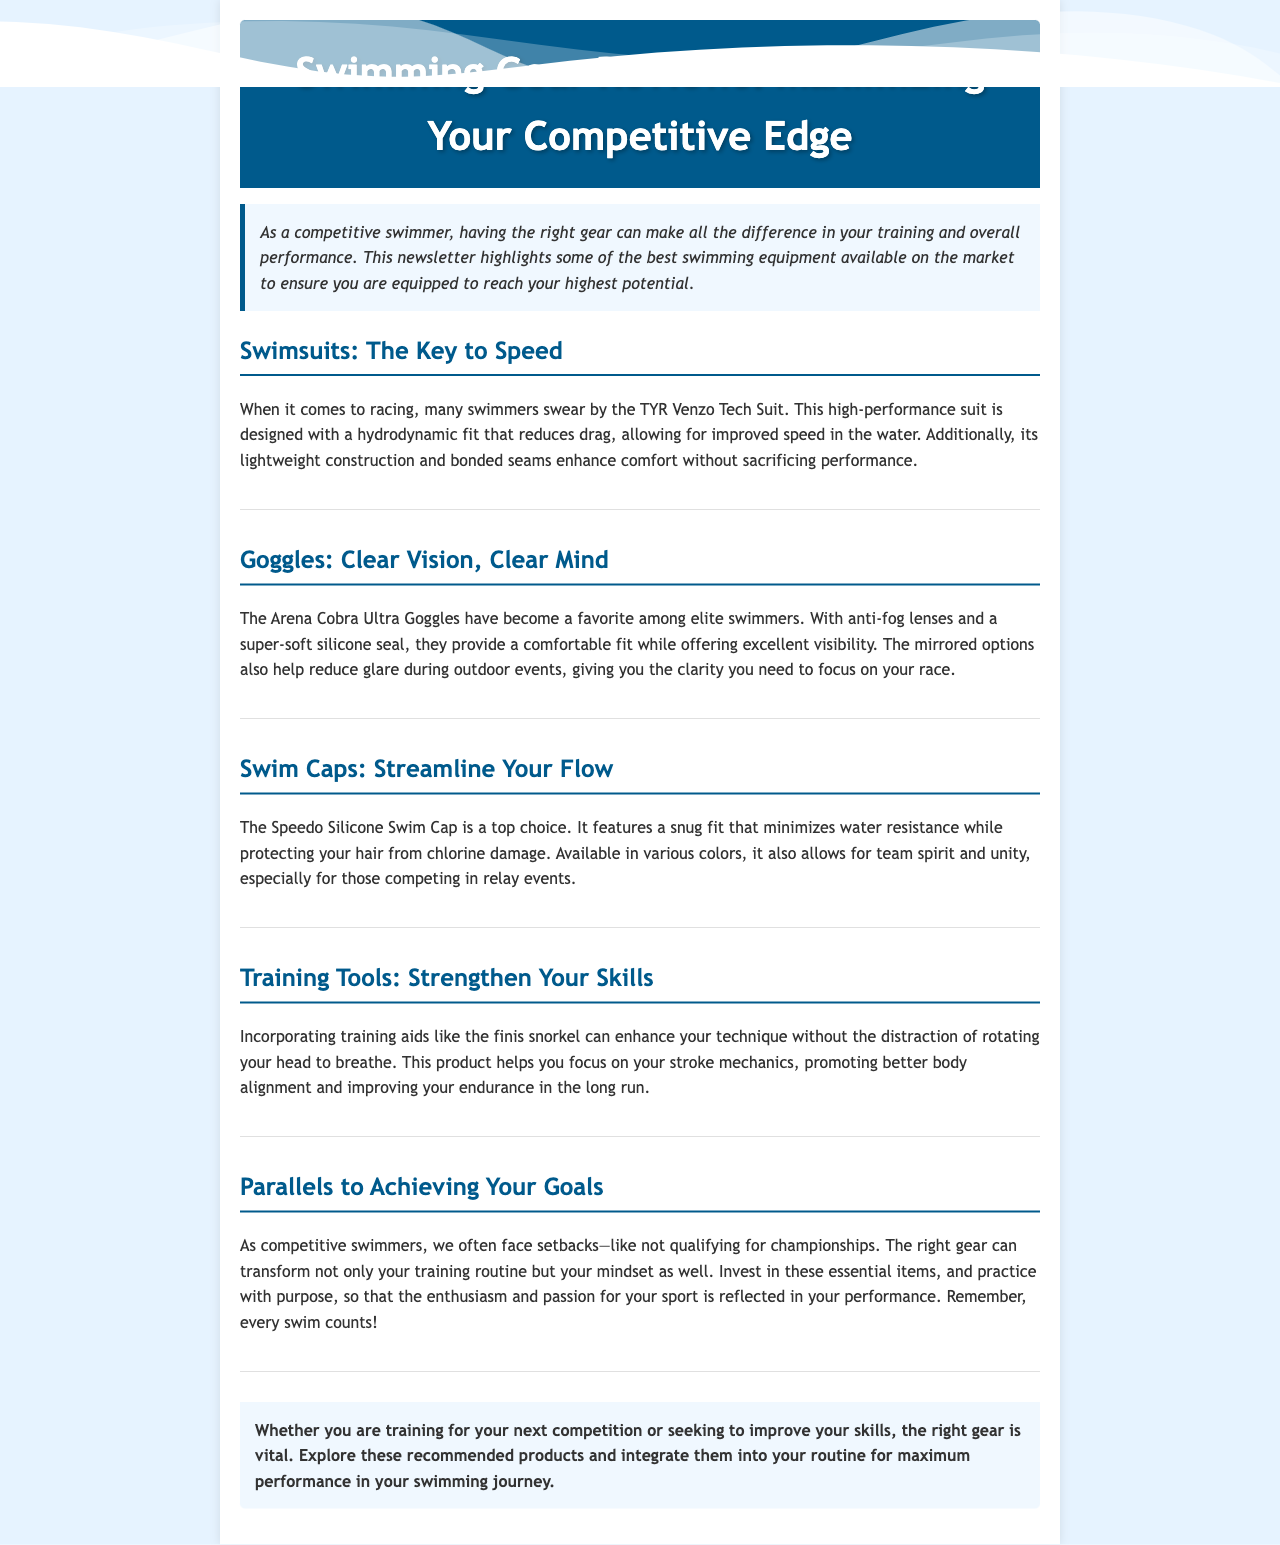What is the name of the recommended tech suit? The document states that the recommended tech suit for racing is the TYR Venzo Tech Suit.
Answer: TYR Venzo Tech Suit What feature improves visibility in the Arena Cobra Ultra Goggles? The goggles feature anti-fog lenses that enhance visibility for swimmers.
Answer: Anti-fog lenses What color options are available for the Speedo Silicone Swim Cap? The document mentions that the Speedo Silicone Swim Cap is available in various colors, allowing for team spirit and unity.
Answer: Various colors Which training aid helps improve stroke mechanics? The Finis snorkel is highlighted as a tool that enhances stroke mechanics by reducing head rotation.
Answer: Finis snorkel How does the document describe setbacks faced by competitive swimmers? The document addresses setbacks as challenges that competitive swimmers often face, such as not qualifying for championships.
Answer: Challenges What is emphasized about the right gear in the closing remarks? The closing remarks highlight the vital importance of having the right gear for training and competition to maximize performance.
Answer: Vital importance What is the main purpose of the newsletter? The newsletter aims to review swimming gear that can help competitive swimmers maximize their training potential.
Answer: Review swimming gear 